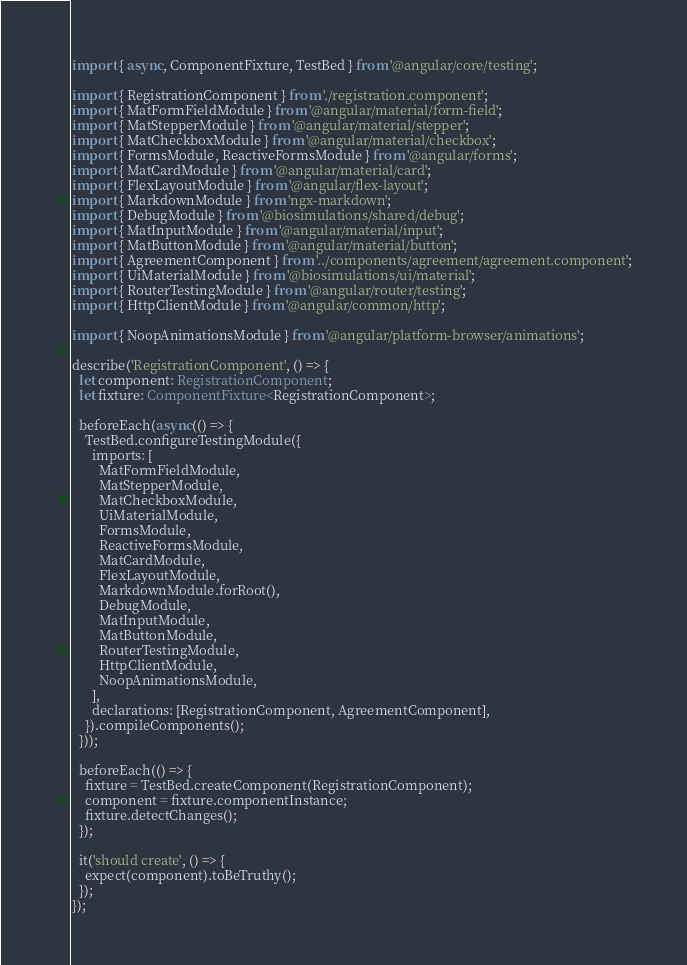<code> <loc_0><loc_0><loc_500><loc_500><_TypeScript_>import { async, ComponentFixture, TestBed } from '@angular/core/testing';

import { RegistrationComponent } from './registration.component';
import { MatFormFieldModule } from '@angular/material/form-field';
import { MatStepperModule } from '@angular/material/stepper';
import { MatCheckboxModule } from '@angular/material/checkbox';
import { FormsModule, ReactiveFormsModule } from '@angular/forms';
import { MatCardModule } from '@angular/material/card';
import { FlexLayoutModule } from '@angular/flex-layout';
import { MarkdownModule } from 'ngx-markdown';
import { DebugModule } from '@biosimulations/shared/debug';
import { MatInputModule } from '@angular/material/input';
import { MatButtonModule } from '@angular/material/button';
import { AgreementComponent } from '../components/agreement/agreement.component';
import { UiMaterialModule } from '@biosimulations/ui/material';
import { RouterTestingModule } from '@angular/router/testing';
import { HttpClientModule } from '@angular/common/http';

import { NoopAnimationsModule } from '@angular/platform-browser/animations';

describe('RegistrationComponent', () => {
  let component: RegistrationComponent;
  let fixture: ComponentFixture<RegistrationComponent>;

  beforeEach(async(() => {
    TestBed.configureTestingModule({
      imports: [
        MatFormFieldModule,
        MatStepperModule,
        MatCheckboxModule,
        UiMaterialModule,
        FormsModule,
        ReactiveFormsModule,
        MatCardModule,
        FlexLayoutModule,
        MarkdownModule.forRoot(),
        DebugModule,
        MatInputModule,
        MatButtonModule,
        RouterTestingModule,
        HttpClientModule,
        NoopAnimationsModule,
      ],
      declarations: [RegistrationComponent, AgreementComponent],
    }).compileComponents();
  }));

  beforeEach(() => {
    fixture = TestBed.createComponent(RegistrationComponent);
    component = fixture.componentInstance;
    fixture.detectChanges();
  });

  it('should create', () => {
    expect(component).toBeTruthy();
  });
});
</code> 